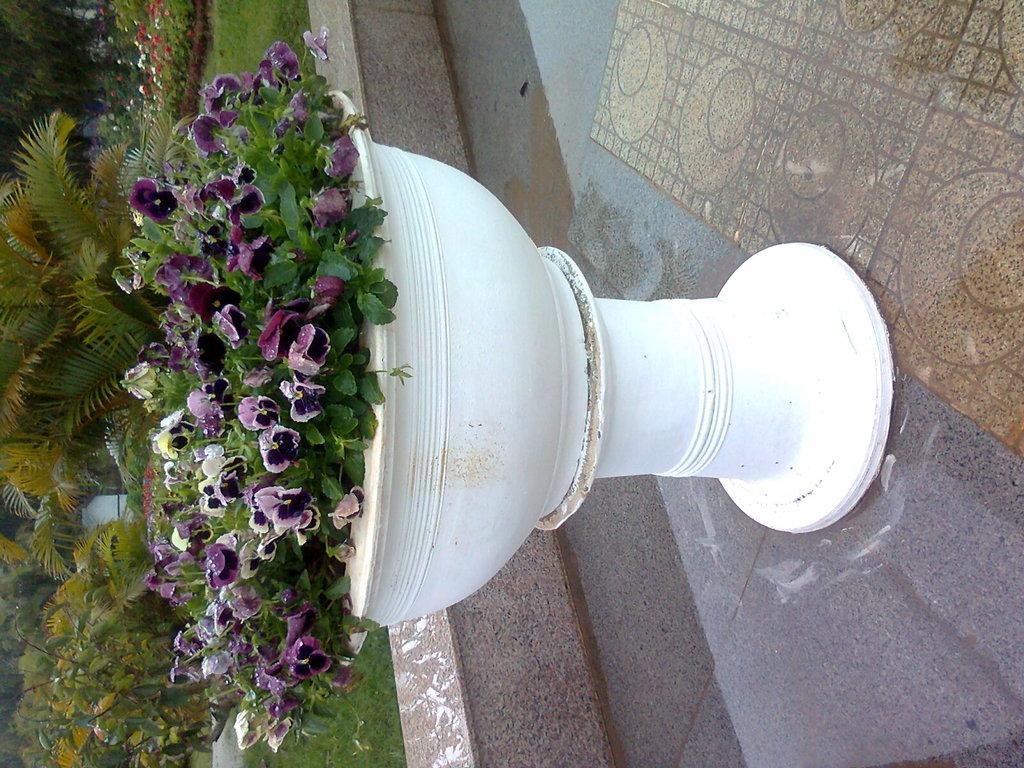Could you give a brief overview of what you see in this image? In the picture we can see a plant in the bowl with a stand which is white in color and the flowers are violet in color and in the background we can see a grass surface and some plants on it. 